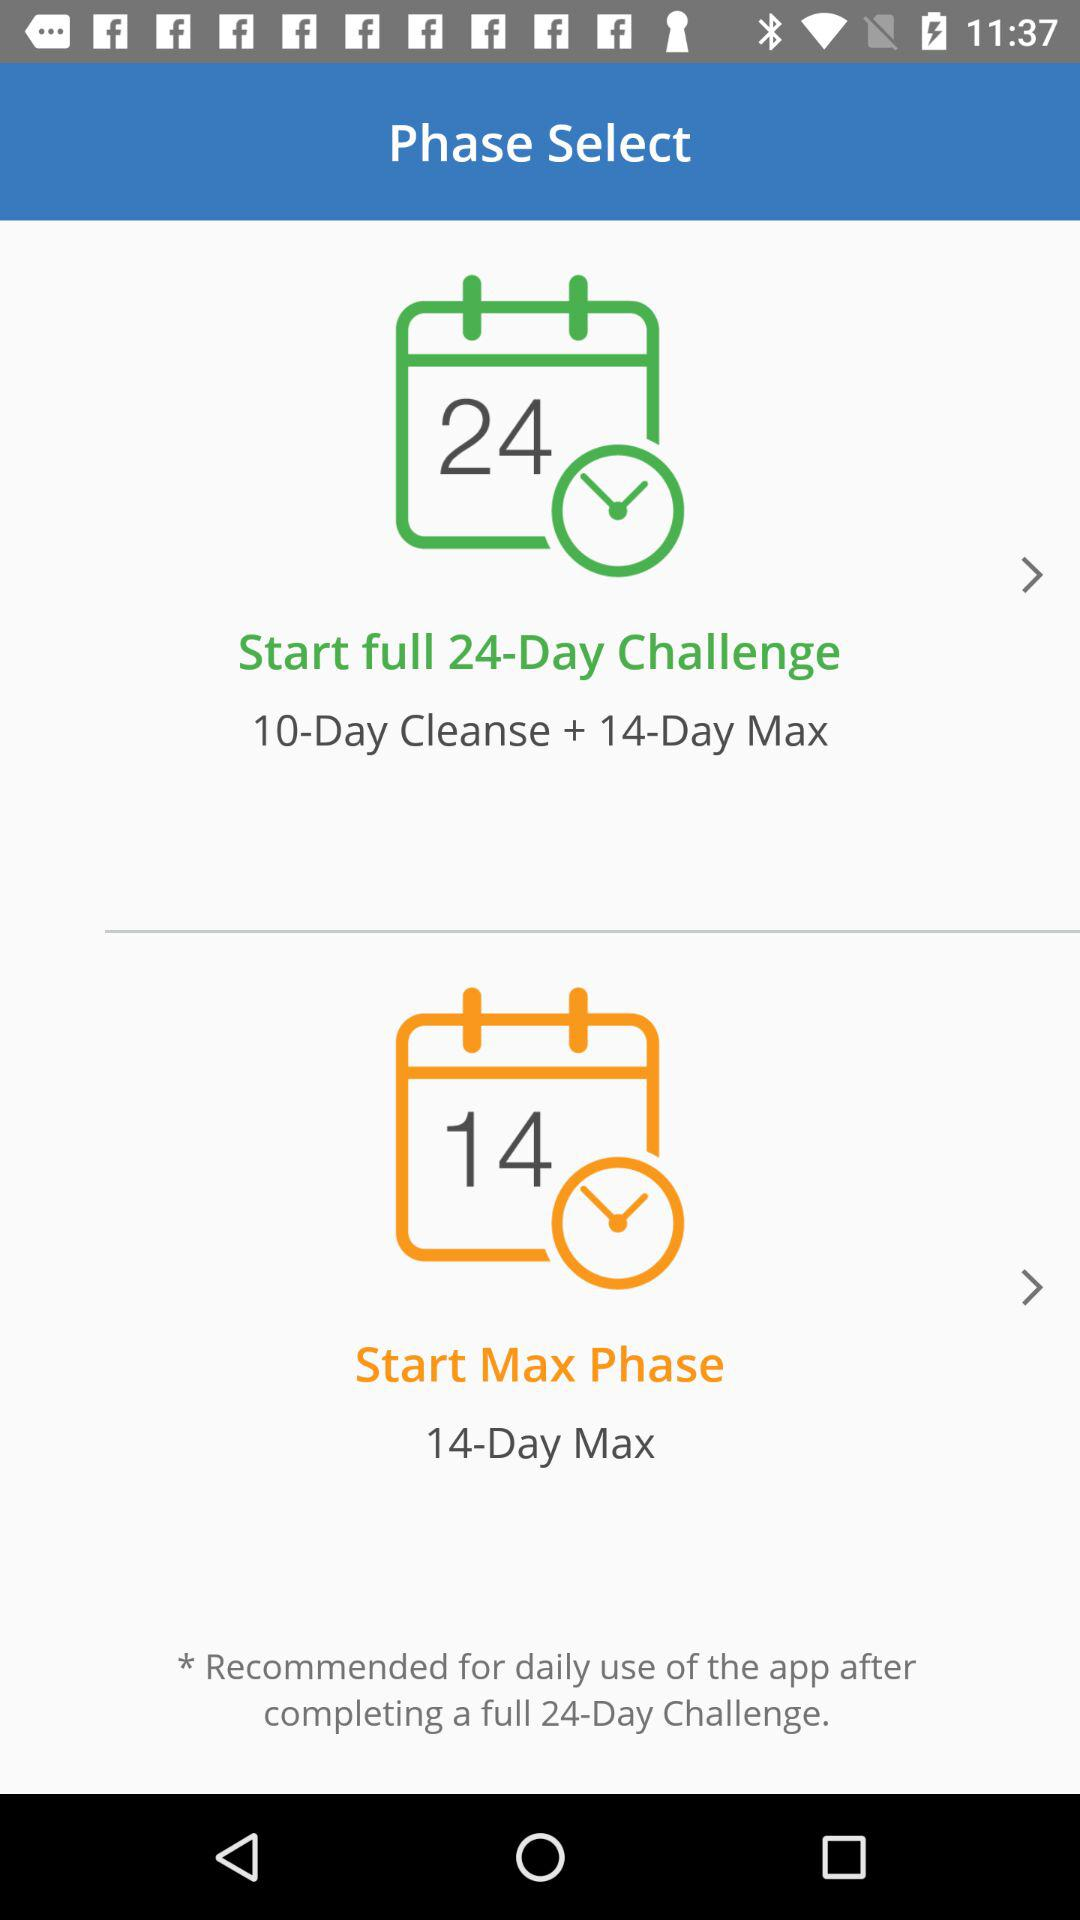How many days are in the Max Phase?
Answer the question using a single word or phrase. 14 